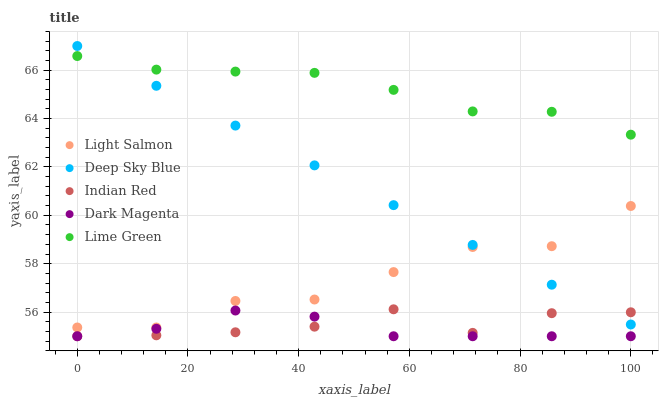Does Dark Magenta have the minimum area under the curve?
Answer yes or no. Yes. Does Lime Green have the maximum area under the curve?
Answer yes or no. Yes. Does Indian Red have the minimum area under the curve?
Answer yes or no. No. Does Indian Red have the maximum area under the curve?
Answer yes or no. No. Is Deep Sky Blue the smoothest?
Answer yes or no. Yes. Is Light Salmon the roughest?
Answer yes or no. Yes. Is Lime Green the smoothest?
Answer yes or no. No. Is Lime Green the roughest?
Answer yes or no. No. Does Indian Red have the lowest value?
Answer yes or no. Yes. Does Lime Green have the lowest value?
Answer yes or no. No. Does Deep Sky Blue have the highest value?
Answer yes or no. Yes. Does Lime Green have the highest value?
Answer yes or no. No. Is Indian Red less than Lime Green?
Answer yes or no. Yes. Is Lime Green greater than Light Salmon?
Answer yes or no. Yes. Does Dark Magenta intersect Indian Red?
Answer yes or no. Yes. Is Dark Magenta less than Indian Red?
Answer yes or no. No. Is Dark Magenta greater than Indian Red?
Answer yes or no. No. Does Indian Red intersect Lime Green?
Answer yes or no. No. 